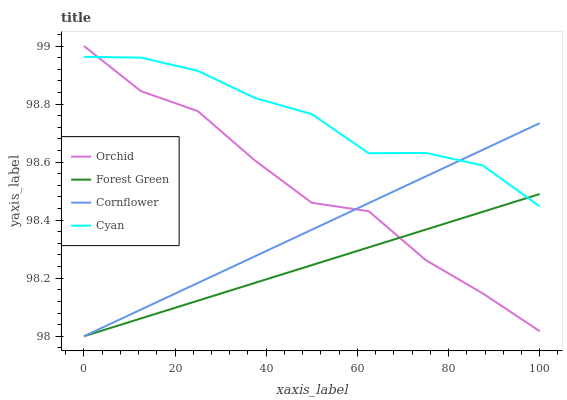Does Forest Green have the minimum area under the curve?
Answer yes or no. Yes. Does Cyan have the maximum area under the curve?
Answer yes or no. Yes. Does Cyan have the minimum area under the curve?
Answer yes or no. No. Does Forest Green have the maximum area under the curve?
Answer yes or no. No. Is Cornflower the smoothest?
Answer yes or no. Yes. Is Orchid the roughest?
Answer yes or no. Yes. Is Cyan the smoothest?
Answer yes or no. No. Is Cyan the roughest?
Answer yes or no. No. Does Cornflower have the lowest value?
Answer yes or no. Yes. Does Cyan have the lowest value?
Answer yes or no. No. Does Orchid have the highest value?
Answer yes or no. Yes. Does Cyan have the highest value?
Answer yes or no. No. Does Cyan intersect Forest Green?
Answer yes or no. Yes. Is Cyan less than Forest Green?
Answer yes or no. No. Is Cyan greater than Forest Green?
Answer yes or no. No. 